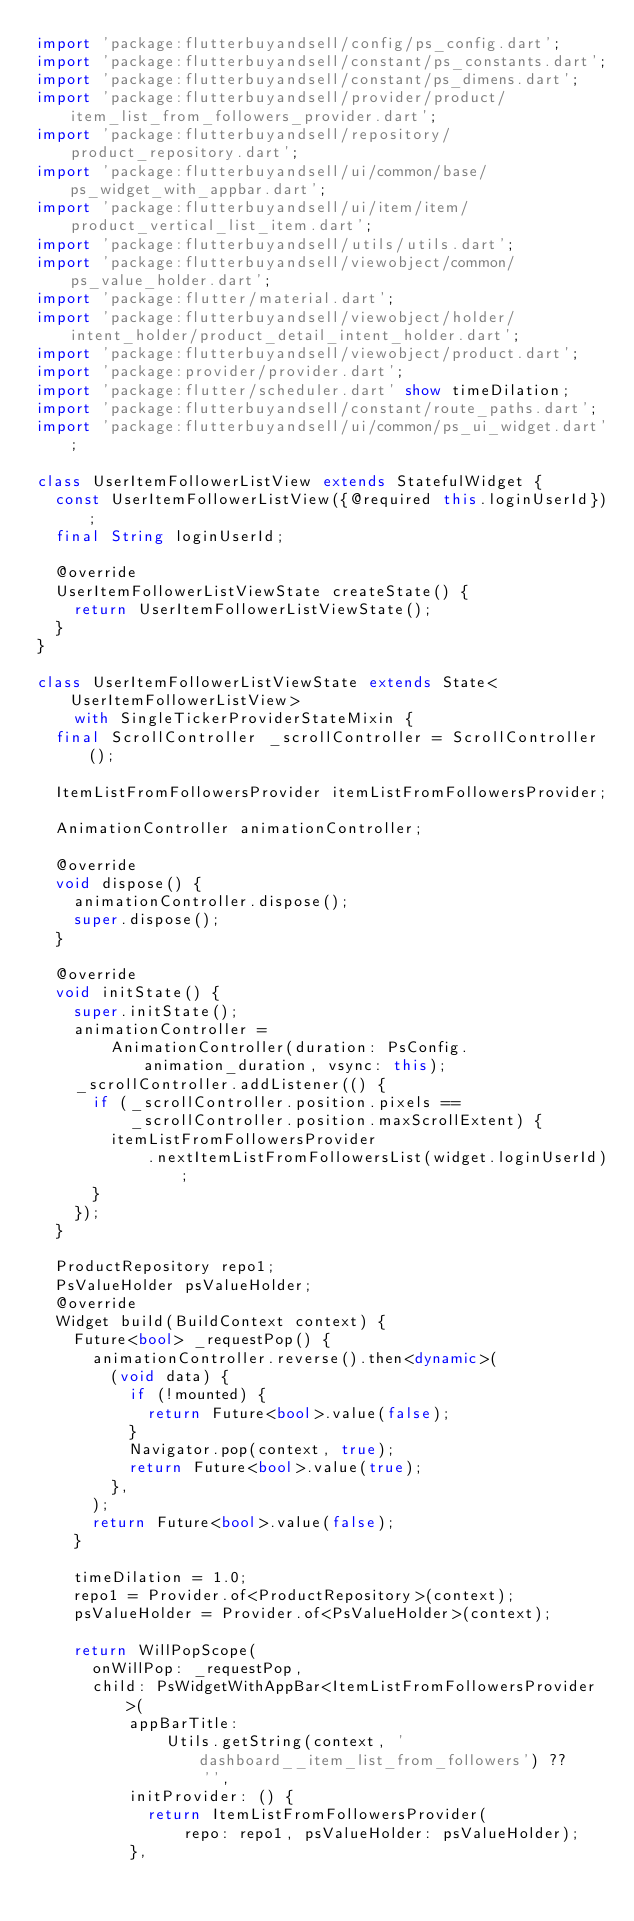<code> <loc_0><loc_0><loc_500><loc_500><_Dart_>import 'package:flutterbuyandsell/config/ps_config.dart';
import 'package:flutterbuyandsell/constant/ps_constants.dart';
import 'package:flutterbuyandsell/constant/ps_dimens.dart';
import 'package:flutterbuyandsell/provider/product/item_list_from_followers_provider.dart';
import 'package:flutterbuyandsell/repository/product_repository.dart';
import 'package:flutterbuyandsell/ui/common/base/ps_widget_with_appbar.dart';
import 'package:flutterbuyandsell/ui/item/item/product_vertical_list_item.dart';
import 'package:flutterbuyandsell/utils/utils.dart';
import 'package:flutterbuyandsell/viewobject/common/ps_value_holder.dart';
import 'package:flutter/material.dart';
import 'package:flutterbuyandsell/viewobject/holder/intent_holder/product_detail_intent_holder.dart';
import 'package:flutterbuyandsell/viewobject/product.dart';
import 'package:provider/provider.dart';
import 'package:flutter/scheduler.dart' show timeDilation;
import 'package:flutterbuyandsell/constant/route_paths.dart';
import 'package:flutterbuyandsell/ui/common/ps_ui_widget.dart';

class UserItemFollowerListView extends StatefulWidget {
  const UserItemFollowerListView({@required this.loginUserId});
  final String loginUserId;

  @override
  UserItemFollowerListViewState createState() {
    return UserItemFollowerListViewState();
  }
}

class UserItemFollowerListViewState extends State<UserItemFollowerListView>
    with SingleTickerProviderStateMixin {
  final ScrollController _scrollController = ScrollController();

  ItemListFromFollowersProvider itemListFromFollowersProvider;

  AnimationController animationController;

  @override
  void dispose() {
    animationController.dispose();
    super.dispose();
  }

  @override
  void initState() {
    super.initState();
    animationController =
        AnimationController(duration: PsConfig.animation_duration, vsync: this);
    _scrollController.addListener(() {
      if (_scrollController.position.pixels ==
          _scrollController.position.maxScrollExtent) {
        itemListFromFollowersProvider
            .nextItemListFromFollowersList(widget.loginUserId);
      }
    });
  }

  ProductRepository repo1;
  PsValueHolder psValueHolder;
  @override
  Widget build(BuildContext context) {
    Future<bool> _requestPop() {
      animationController.reverse().then<dynamic>(
        (void data) {
          if (!mounted) {
            return Future<bool>.value(false);
          }
          Navigator.pop(context, true);
          return Future<bool>.value(true);
        },
      );
      return Future<bool>.value(false);
    }

    timeDilation = 1.0;
    repo1 = Provider.of<ProductRepository>(context);
    psValueHolder = Provider.of<PsValueHolder>(context);

    return WillPopScope(
      onWillPop: _requestPop,
      child: PsWidgetWithAppBar<ItemListFromFollowersProvider>(
          appBarTitle:
              Utils.getString(context, 'dashboard__item_list_from_followers') ??
                  '',
          initProvider: () {
            return ItemListFromFollowersProvider(
                repo: repo1, psValueHolder: psValueHolder);
          },</code> 